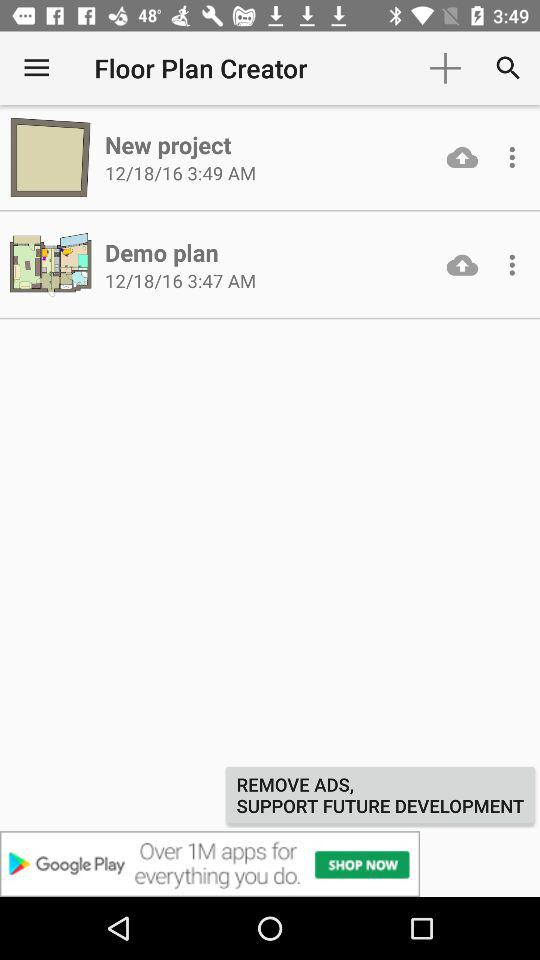At what time is the Demo Plan folder created? The Demo Plan folder was created at 3:47 AM. 